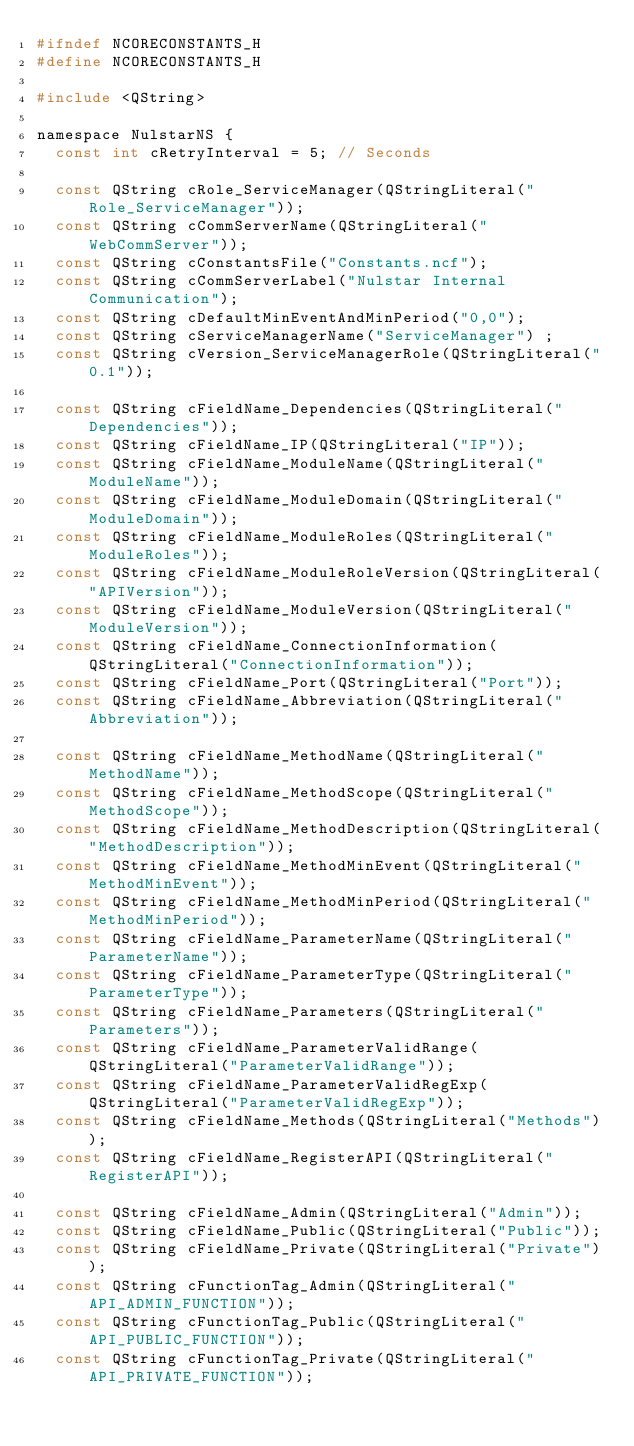<code> <loc_0><loc_0><loc_500><loc_500><_C_>#ifndef NCORECONSTANTS_H
#define NCORECONSTANTS_H

#include <QString>

namespace NulstarNS {
  const int cRetryInterval = 5; // Seconds

  const QString cRole_ServiceManager(QStringLiteral("Role_ServiceManager"));
  const QString cCommServerName(QStringLiteral("WebCommServer"));
  const QString cConstantsFile("Constants.ncf");
  const QString cCommServerLabel("Nulstar Internal Communication");
  const QString cDefaultMinEventAndMinPeriod("0,0");
  const QString cServiceManagerName("ServiceManager") ;
  const QString cVersion_ServiceManagerRole(QStringLiteral("0.1"));

  const QString cFieldName_Dependencies(QStringLiteral("Dependencies"));
  const QString cFieldName_IP(QStringLiteral("IP"));
  const QString cFieldName_ModuleName(QStringLiteral("ModuleName"));
  const QString cFieldName_ModuleDomain(QStringLiteral("ModuleDomain"));
  const QString cFieldName_ModuleRoles(QStringLiteral("ModuleRoles"));
  const QString cFieldName_ModuleRoleVersion(QStringLiteral("APIVersion"));
  const QString cFieldName_ModuleVersion(QStringLiteral("ModuleVersion"));
  const QString cFieldName_ConnectionInformation(QStringLiteral("ConnectionInformation"));
  const QString cFieldName_Port(QStringLiteral("Port"));
  const QString cFieldName_Abbreviation(QStringLiteral("Abbreviation"));

  const QString cFieldName_MethodName(QStringLiteral("MethodName"));
  const QString cFieldName_MethodScope(QStringLiteral("MethodScope"));
  const QString cFieldName_MethodDescription(QStringLiteral("MethodDescription"));
  const QString cFieldName_MethodMinEvent(QStringLiteral("MethodMinEvent"));
  const QString cFieldName_MethodMinPeriod(QStringLiteral("MethodMinPeriod"));
  const QString cFieldName_ParameterName(QStringLiteral("ParameterName"));
  const QString cFieldName_ParameterType(QStringLiteral("ParameterType"));
  const QString cFieldName_Parameters(QStringLiteral("Parameters"));
  const QString cFieldName_ParameterValidRange(QStringLiteral("ParameterValidRange"));
  const QString cFieldName_ParameterValidRegExp(QStringLiteral("ParameterValidRegExp"));
  const QString cFieldName_Methods(QStringLiteral("Methods"));
  const QString cFieldName_RegisterAPI(QStringLiteral("RegisterAPI"));

  const QString cFieldName_Admin(QStringLiteral("Admin"));
  const QString cFieldName_Public(QStringLiteral("Public"));
  const QString cFieldName_Private(QStringLiteral("Private"));
  const QString cFunctionTag_Admin(QStringLiteral("API_ADMIN_FUNCTION"));
  const QString cFunctionTag_Public(QStringLiteral("API_PUBLIC_FUNCTION"));
  const QString cFunctionTag_Private(QStringLiteral("API_PRIVATE_FUNCTION"));
</code> 